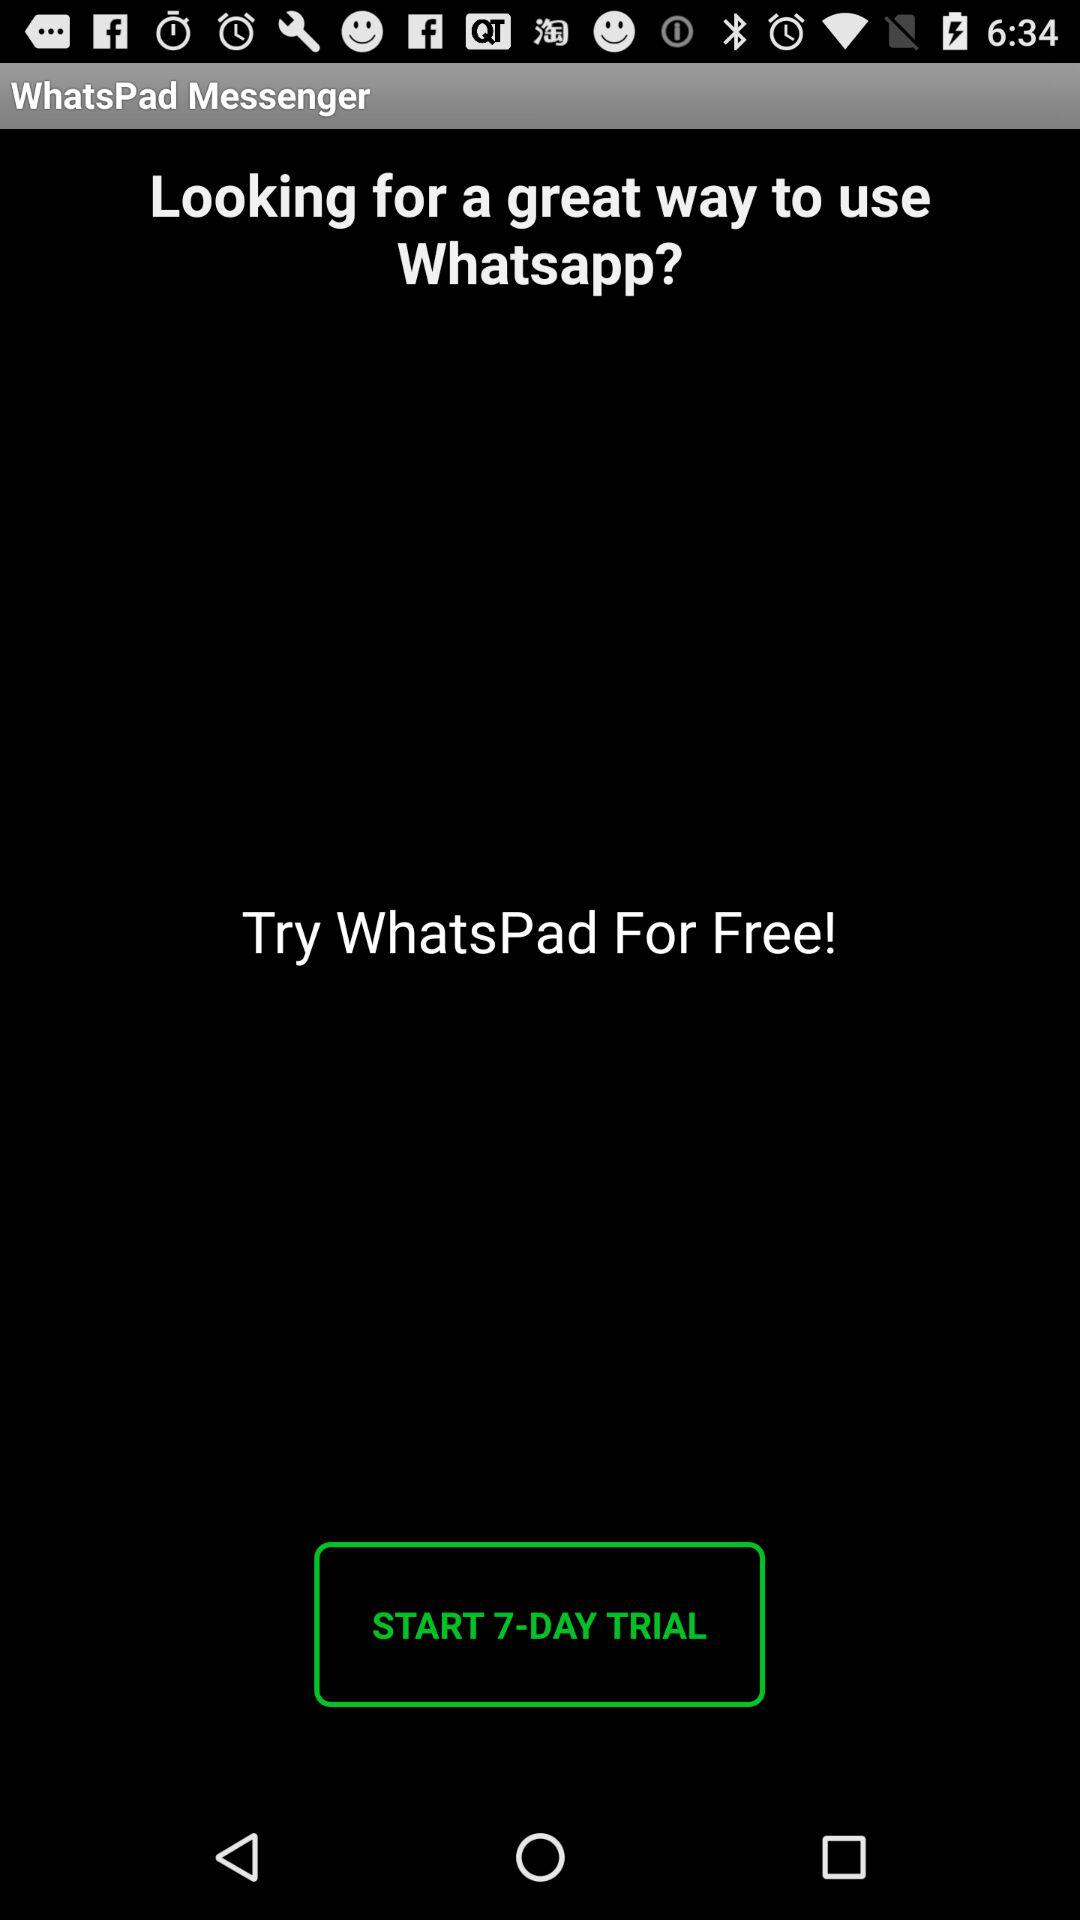For how many days is the trial available? The trial is available for 7 days. 